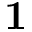Convert formula to latex. <formula><loc_0><loc_0><loc_500><loc_500>{ 1 }</formula> 